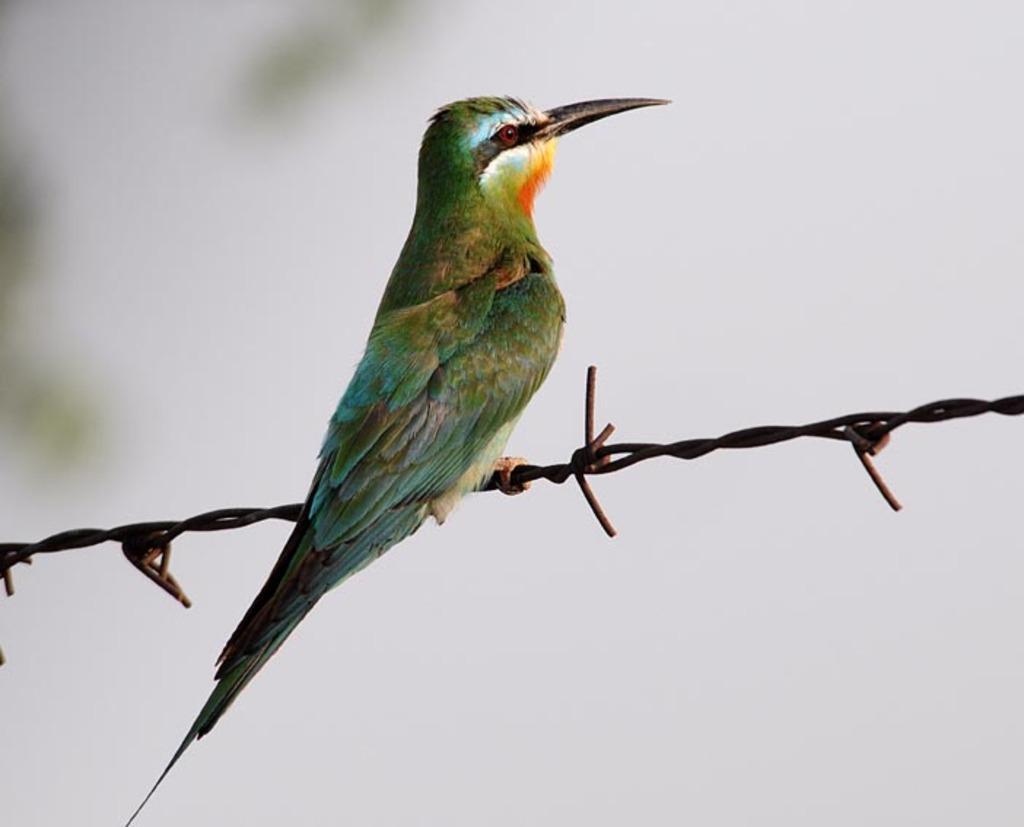Describe this image in one or two sentences. In the foreground of this image, there is a beautiful bird on a barbed wire. In the background, there is the sky. 